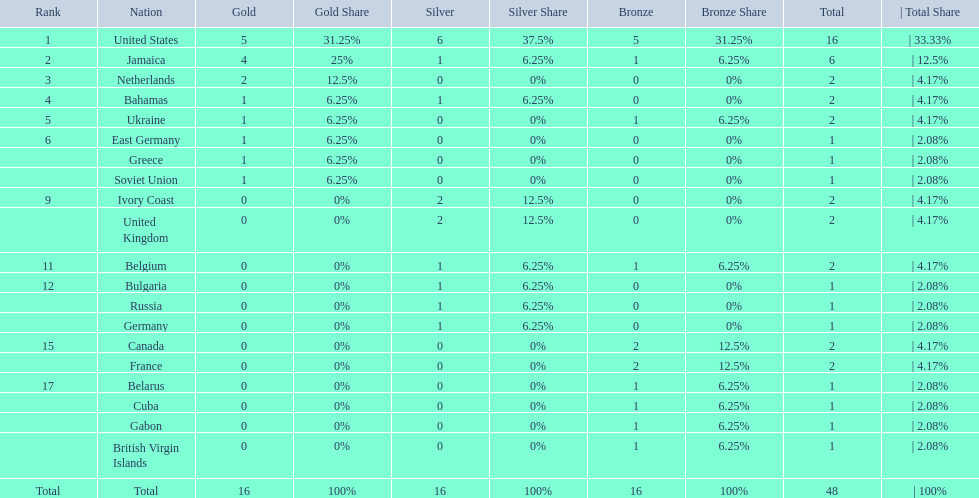What country won the most medals? United States. How many medals did the us win? 16. What is the most medals (after 16) that were won by a country? 6. Which country won 6 medals? Jamaica. 